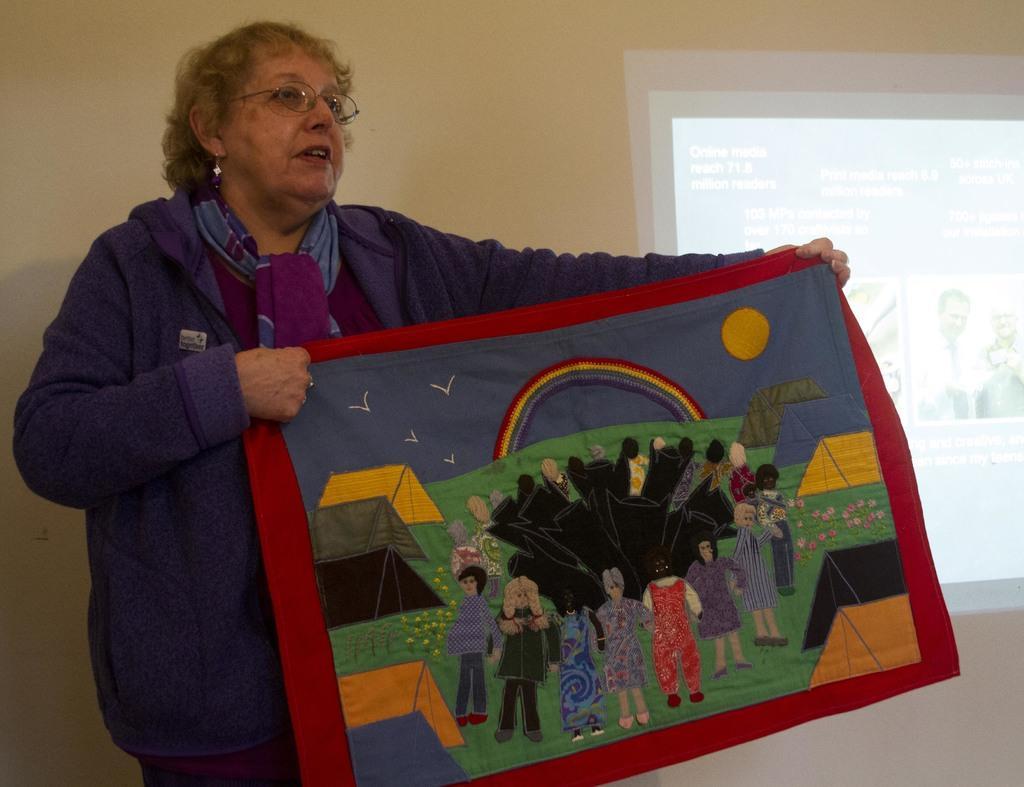Please provide a concise description of this image. In this image we can see a holding a cloth in which we can see some people and behind her we can see the screen. 